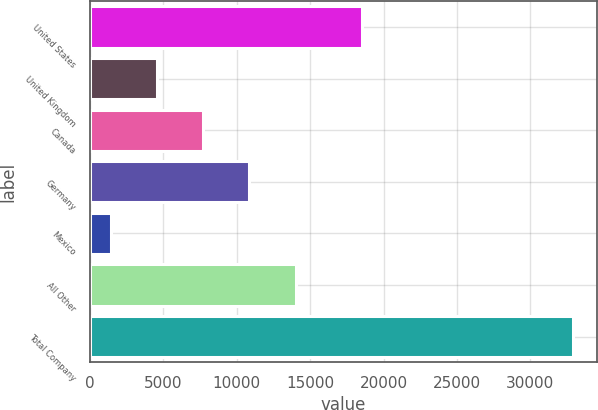<chart> <loc_0><loc_0><loc_500><loc_500><bar_chart><fcel>United States<fcel>United Kingdom<fcel>Canada<fcel>Germany<fcel>Mexico<fcel>All Other<fcel>Total Company<nl><fcel>18514<fcel>4566.2<fcel>7713.4<fcel>10860.6<fcel>1419<fcel>14007.8<fcel>32891<nl></chart> 